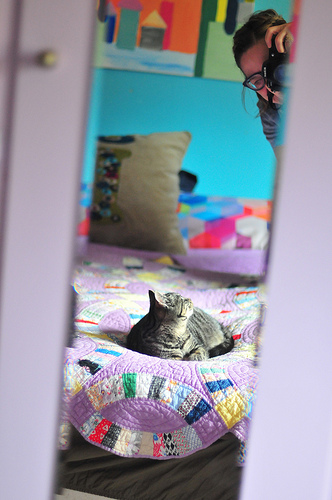<image>
Is the glasses above the cat? Yes. The glasses is positioned above the cat in the vertical space, higher up in the scene. 